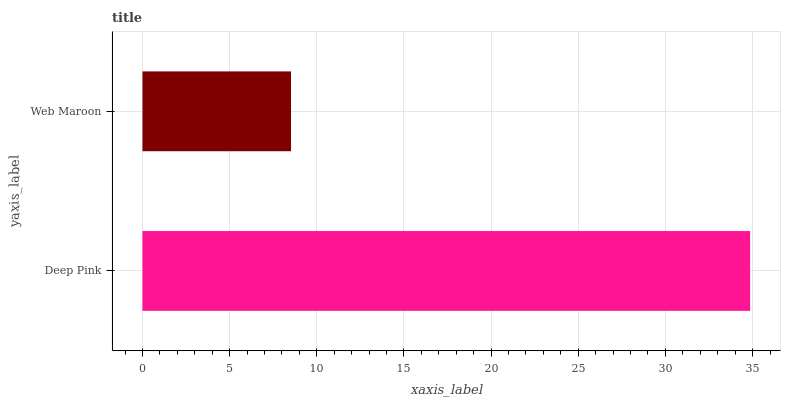Is Web Maroon the minimum?
Answer yes or no. Yes. Is Deep Pink the maximum?
Answer yes or no. Yes. Is Web Maroon the maximum?
Answer yes or no. No. Is Deep Pink greater than Web Maroon?
Answer yes or no. Yes. Is Web Maroon less than Deep Pink?
Answer yes or no. Yes. Is Web Maroon greater than Deep Pink?
Answer yes or no. No. Is Deep Pink less than Web Maroon?
Answer yes or no. No. Is Deep Pink the high median?
Answer yes or no. Yes. Is Web Maroon the low median?
Answer yes or no. Yes. Is Web Maroon the high median?
Answer yes or no. No. Is Deep Pink the low median?
Answer yes or no. No. 